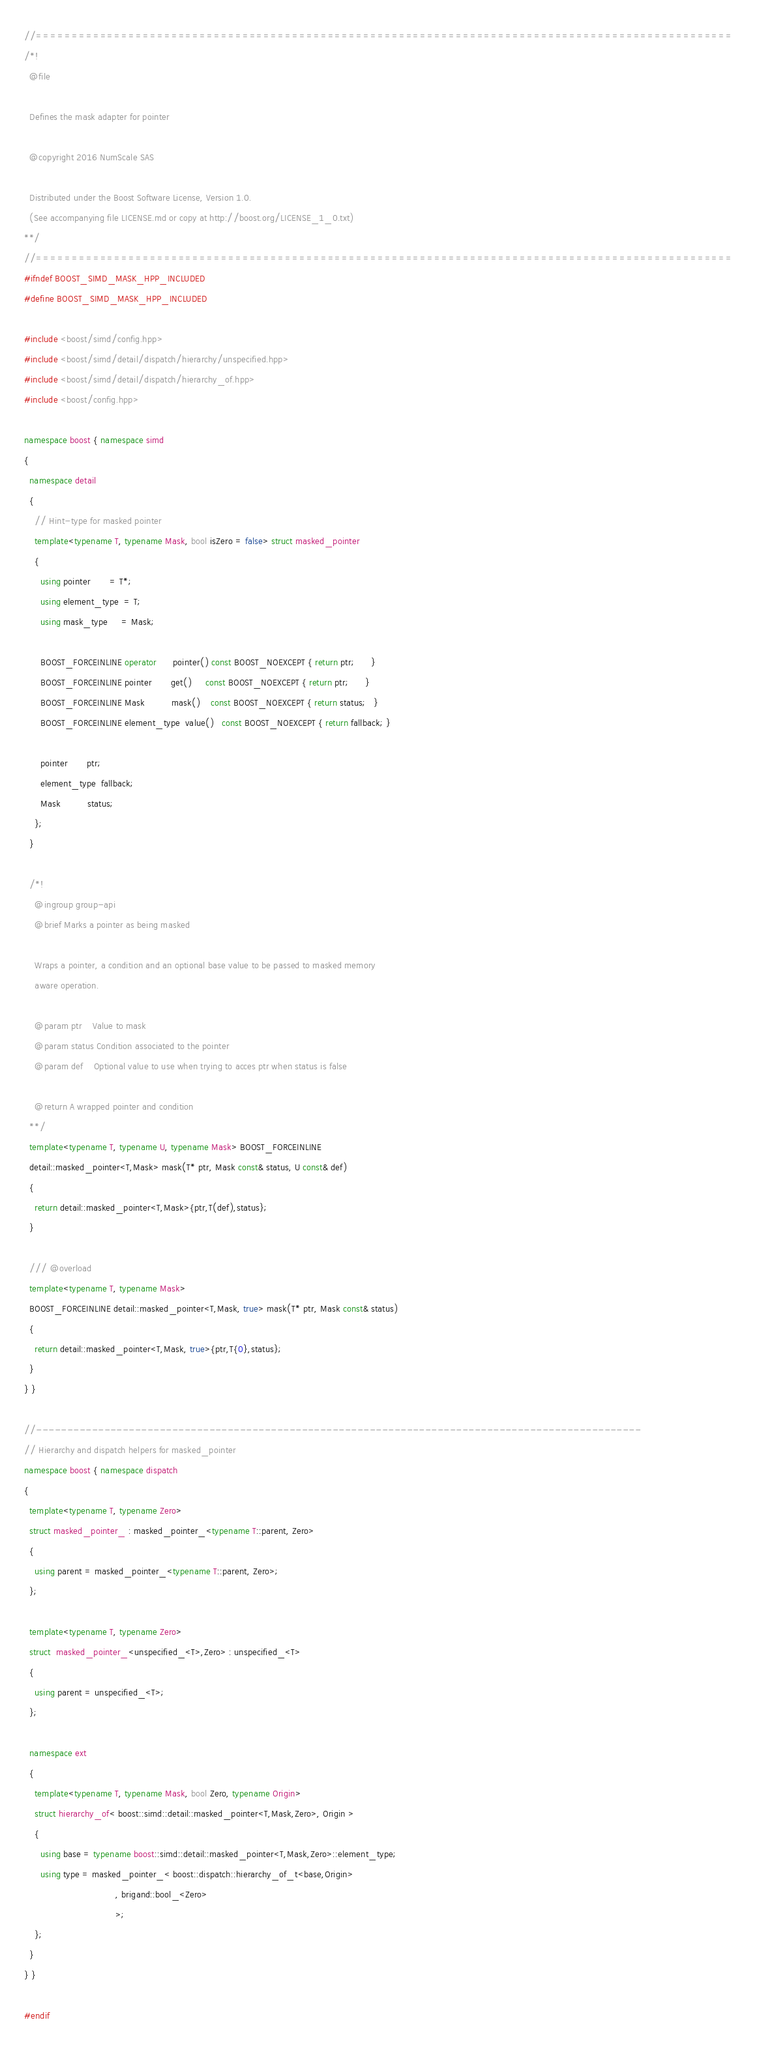<code> <loc_0><loc_0><loc_500><loc_500><_C++_>//==================================================================================================
/*!
  @file

  Defines the mask adapter for pointer

  @copyright 2016 NumScale SAS

  Distributed under the Boost Software License, Version 1.0.
  (See accompanying file LICENSE.md or copy at http://boost.org/LICENSE_1_0.txt)
**/
//==================================================================================================
#ifndef BOOST_SIMD_MASK_HPP_INCLUDED
#define BOOST_SIMD_MASK_HPP_INCLUDED

#include <boost/simd/config.hpp>
#include <boost/simd/detail/dispatch/hierarchy/unspecified.hpp>
#include <boost/simd/detail/dispatch/hierarchy_of.hpp>
#include <boost/config.hpp>

namespace boost { namespace simd
{
  namespace detail
  {
    // Hint-type for masked pointer
    template<typename T, typename Mask, bool isZero = false> struct masked_pointer
    {
      using pointer       = T*;
      using element_type  = T;
      using mask_type     = Mask;

      BOOST_FORCEINLINE operator      pointer() const BOOST_NOEXCEPT { return ptr;      }
      BOOST_FORCEINLINE pointer       get()     const BOOST_NOEXCEPT { return ptr;      }
      BOOST_FORCEINLINE Mask          mask()    const BOOST_NOEXCEPT { return status;   }
      BOOST_FORCEINLINE element_type  value()   const BOOST_NOEXCEPT { return fallback; }

      pointer       ptr;
      element_type  fallback;
      Mask          status;
    };
  }

  /*!
    @ingroup group-api
    @brief Marks a pointer as being masked

    Wraps a pointer, a condition and an optional base value to be passed to masked memory
    aware operation.

    @param ptr    Value to mask
    @param status Condition associated to the pointer
    @param def    Optional value to use when trying to acces ptr when status is false

    @return A wrapped pointer and condition
  **/
  template<typename T, typename U, typename Mask> BOOST_FORCEINLINE
  detail::masked_pointer<T,Mask> mask(T* ptr, Mask const& status, U const& def)
  {
    return detail::masked_pointer<T,Mask>{ptr,T(def),status};
  }

  /// @overload
  template<typename T, typename Mask>
  BOOST_FORCEINLINE detail::masked_pointer<T,Mask, true> mask(T* ptr, Mask const& status)
  {
    return detail::masked_pointer<T,Mask, true>{ptr,T{0},status};
  }
} }

//--------------------------------------------------------------------------------------------------
// Hierarchy and dispatch helpers for masked_pointer
namespace boost { namespace dispatch
{
  template<typename T, typename Zero>
  struct masked_pointer_ : masked_pointer_<typename T::parent, Zero>
  {
    using parent = masked_pointer_<typename T::parent, Zero>;
  };

  template<typename T, typename Zero>
  struct  masked_pointer_<unspecified_<T>,Zero> : unspecified_<T>
  {
    using parent = unspecified_<T>;
  };

  namespace ext
  {
    template<typename T, typename Mask, bool Zero, typename Origin>
    struct hierarchy_of< boost::simd::detail::masked_pointer<T,Mask,Zero>, Origin >
    {
      using base = typename boost::simd::detail::masked_pointer<T,Mask,Zero>::element_type;
      using type = masked_pointer_< boost::dispatch::hierarchy_of_t<base,Origin>
                                  , brigand::bool_<Zero>
                                  >;
    };
  }
} }

#endif
</code> 